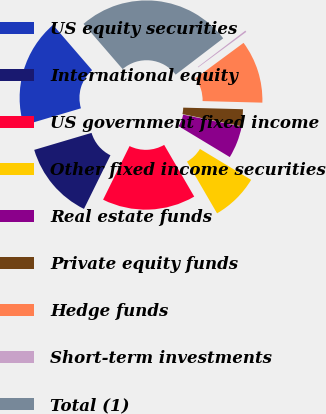<chart> <loc_0><loc_0><loc_500><loc_500><pie_chart><fcel>US equity securities<fcel>International equity<fcel>US government fixed income<fcel>Other fixed income securities<fcel>Real estate funds<fcel>Private equity funds<fcel>Hedge funds<fcel>Short-term investments<fcel>Total (1)<nl><fcel>18.25%<fcel>13.11%<fcel>15.68%<fcel>7.97%<fcel>5.4%<fcel>2.83%<fcel>10.54%<fcel>0.26%<fcel>25.96%<nl></chart> 